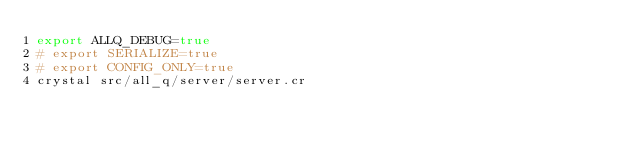Convert code to text. <code><loc_0><loc_0><loc_500><loc_500><_Bash_>export ALLQ_DEBUG=true
# export SERIALIZE=true
# export CONFIG_ONLY=true
crystal src/all_q/server/server.cr
</code> 